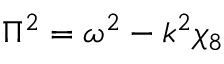Convert formula to latex. <formula><loc_0><loc_0><loc_500><loc_500>\Pi ^ { 2 } = \omega ^ { 2 } - k ^ { 2 } \chi _ { 8 }</formula> 